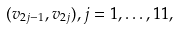Convert formula to latex. <formula><loc_0><loc_0><loc_500><loc_500>( v _ { 2 j - 1 } , v _ { 2 j } ) , j = 1 , \dots , 1 1 ,</formula> 